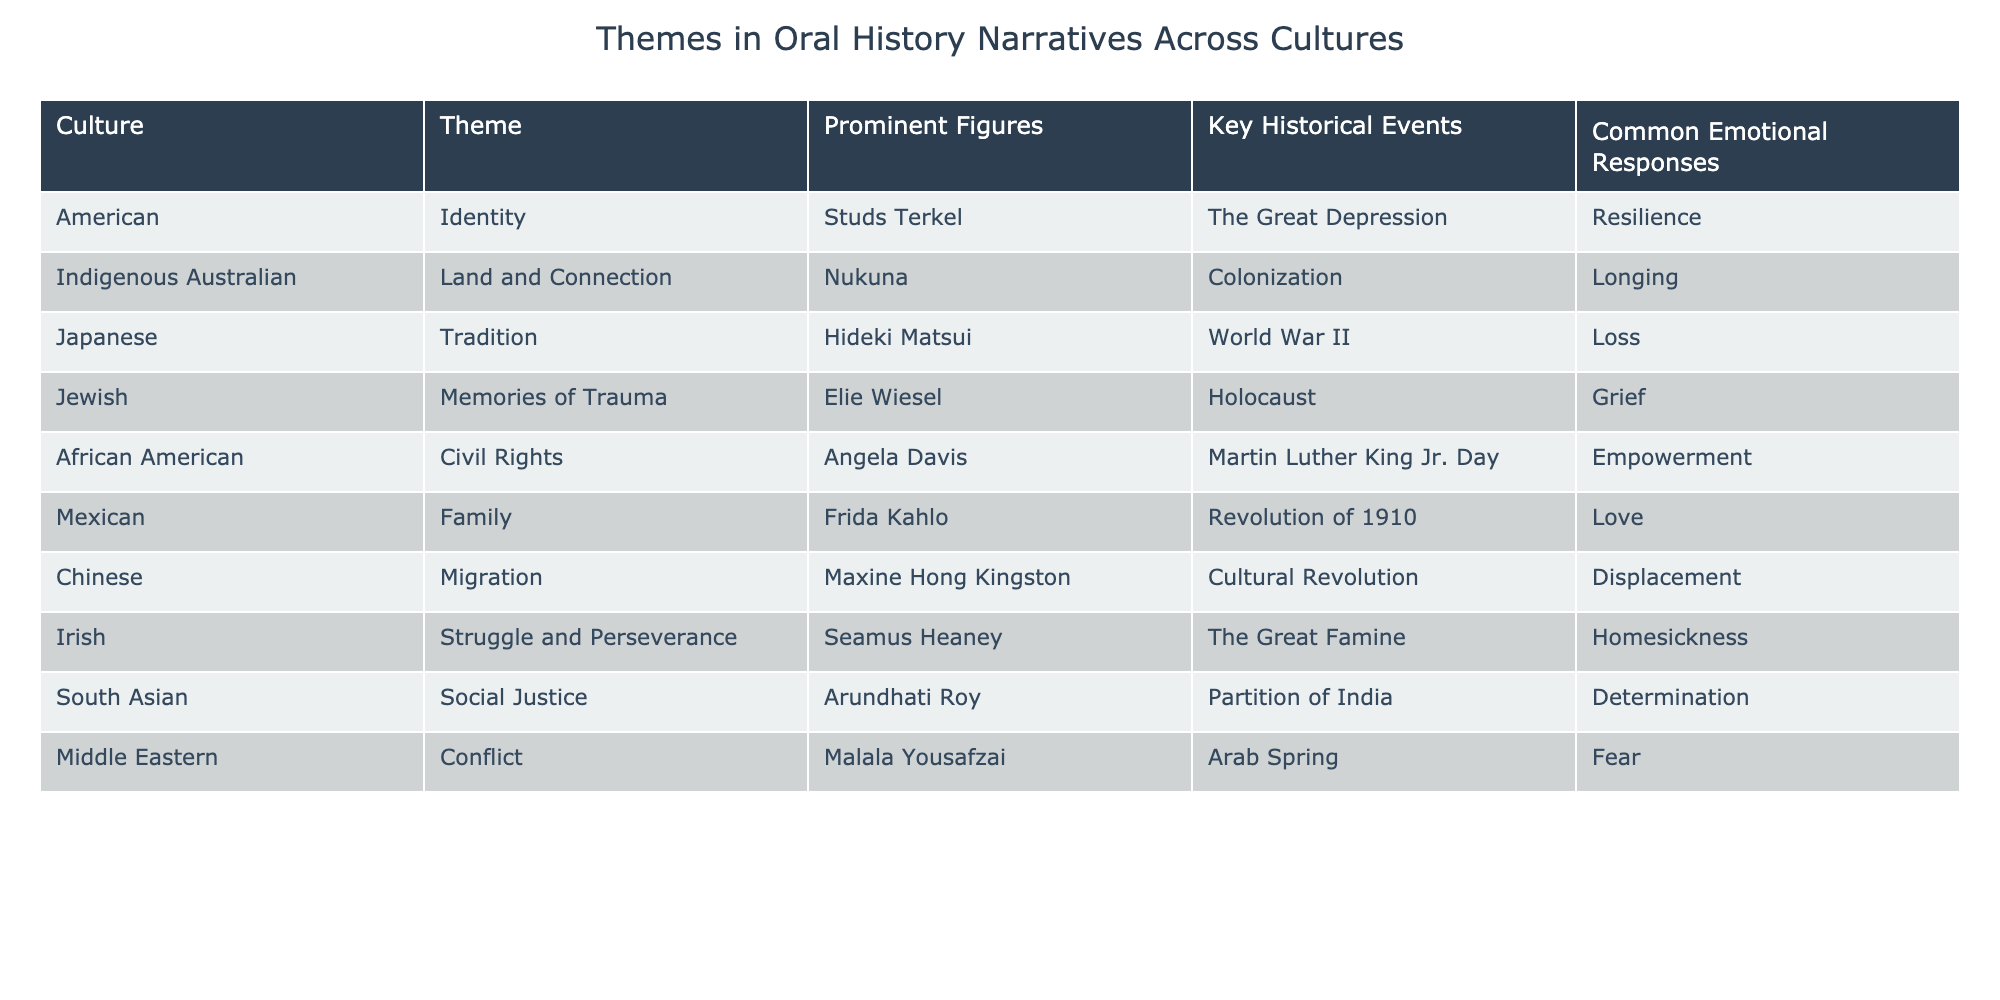What theme is associated with the Jewish culture in the table? The table shows that the theme associated with Jewish culture is "Memories of Trauma".
Answer: Memories of Trauma Which prominent figure is linked to the theme of Identity in American culture? According to the table, the prominent figure linked to the theme of Identity in American culture is Studs Terkel.
Answer: Studs Terkel Are there any cultures in the table that express a common emotional response of Love? The table indicates that the Mexican culture expresses a common emotional response of Love.
Answer: Yes How many cultures in the table have the theme of Struggle and Perseverance? By examining the table, it becomes clear that only the Irish culture has the theme of Struggle and Perseverance.
Answer: One What is the difference in emotional responses between Indigenous Australian and Jewish cultures? The emotional response for Indigenous Australian culture is Longing while for Jewish culture it is Grief. The difference lies in the emotional depth and context of their respective histories, although both exhibit a sense of loss.
Answer: Longing and Grief Which culture has the most recent key historical event listed in the table? Looking at the key historical events, Arab Spring is listed for Middle Eastern culture, which occurred in the 2010s, making it the most recent event.
Answer: Middle Eastern What is the emotional response associated with the theme of Civil Rights in African American culture, and which figure represents this theme? The emotional response associated with the theme of Civil Rights in African American culture is Empowerment, represented by prominent figure Angela Davis.
Answer: Empowerment; Angela Davis Does the table indicate a common theme among non-Western cultures? A close inspection reveals that the themes among non-Western cultures like Indigenous Australian, South Asian, and Middle Eastern do revolve around deep emotional connections to history and conflict, suggesting a common thread.
Answer: Yes How many emotional responses mentioned in the table are characterized by a sense of determination? The table shows that only the South Asian culture lists Determination as an emotional response, indicating a singular occurrence.
Answer: One 